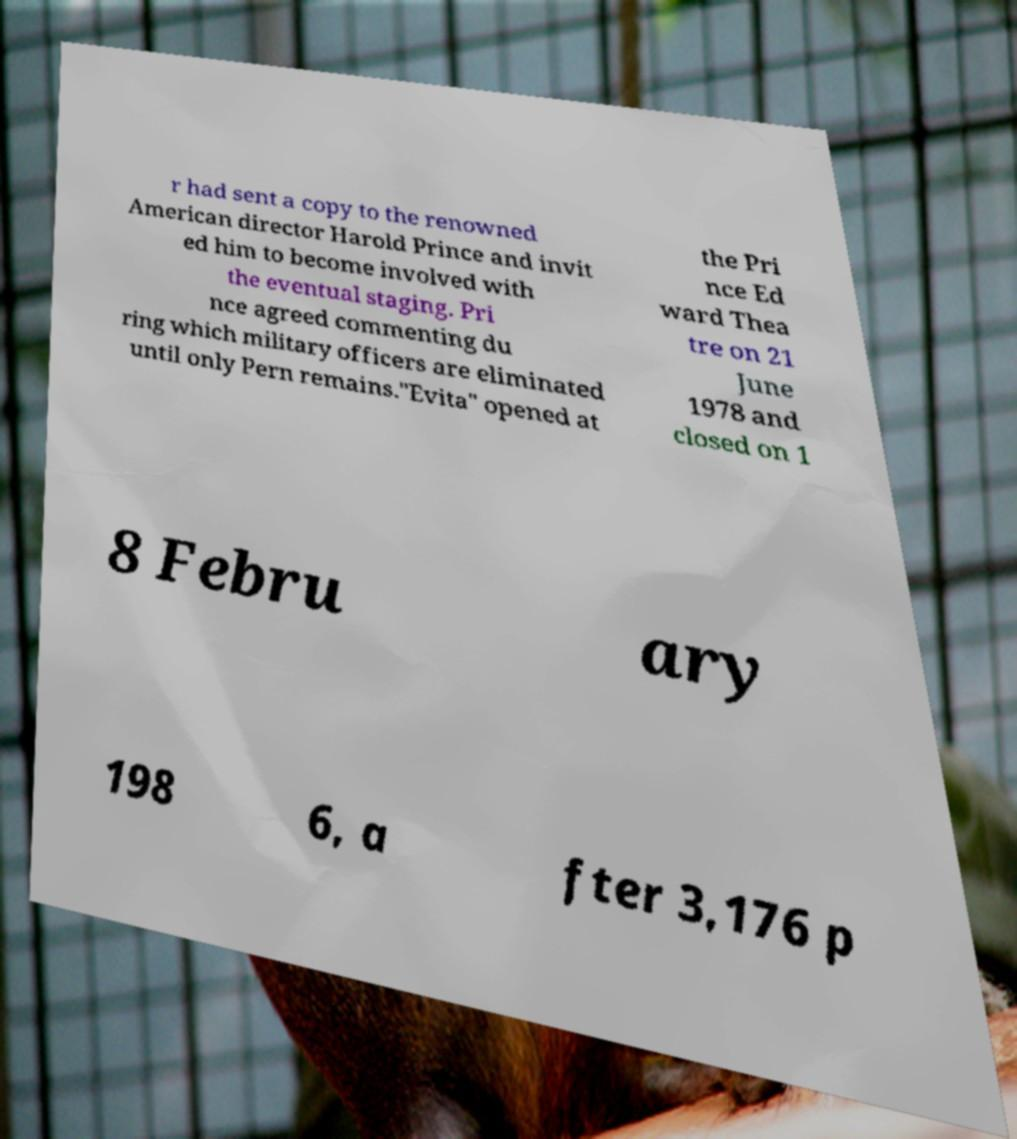I need the written content from this picture converted into text. Can you do that? r had sent a copy to the renowned American director Harold Prince and invit ed him to become involved with the eventual staging. Pri nce agreed commenting du ring which military officers are eliminated until only Pern remains."Evita" opened at the Pri nce Ed ward Thea tre on 21 June 1978 and closed on 1 8 Febru ary 198 6, a fter 3,176 p 